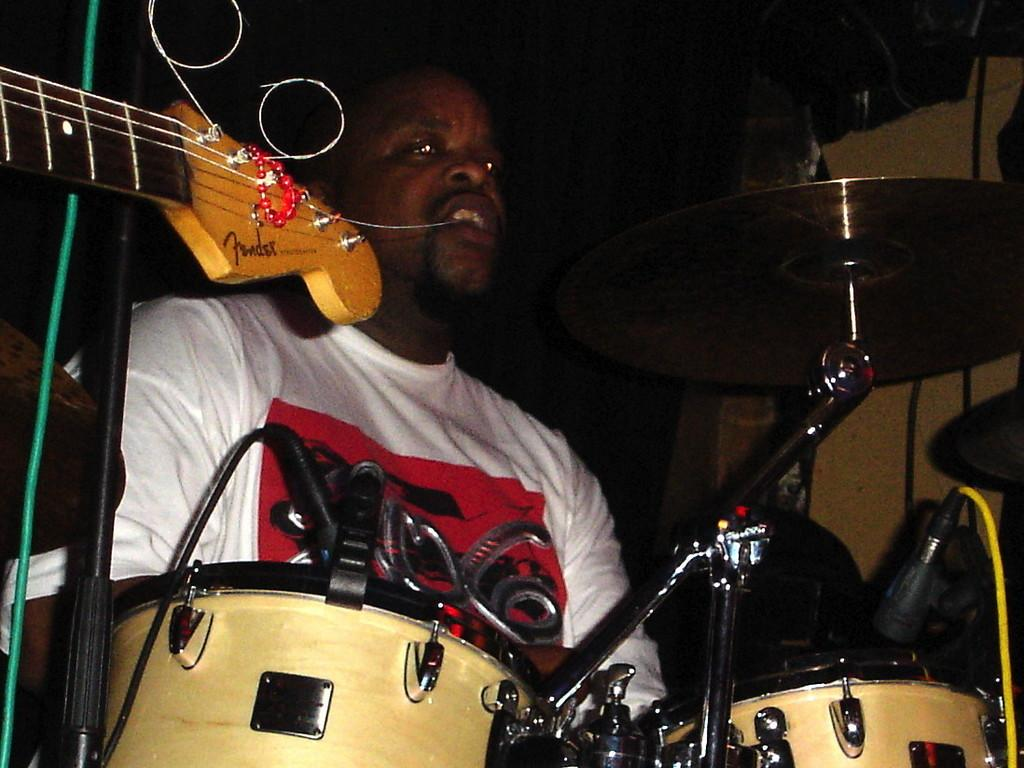Who is the person in the image? There is a man in the image. What is the man doing in the image? The man is sitting and playing drums. What other musical instrument can be seen in the image? There is a guitar on the left side of the image. What type of nerve can be seen in the image? There is no nerve visible in the image; it features a man playing drums and a guitar. Is there a baby present in the image? No, there is no baby present in the image. 